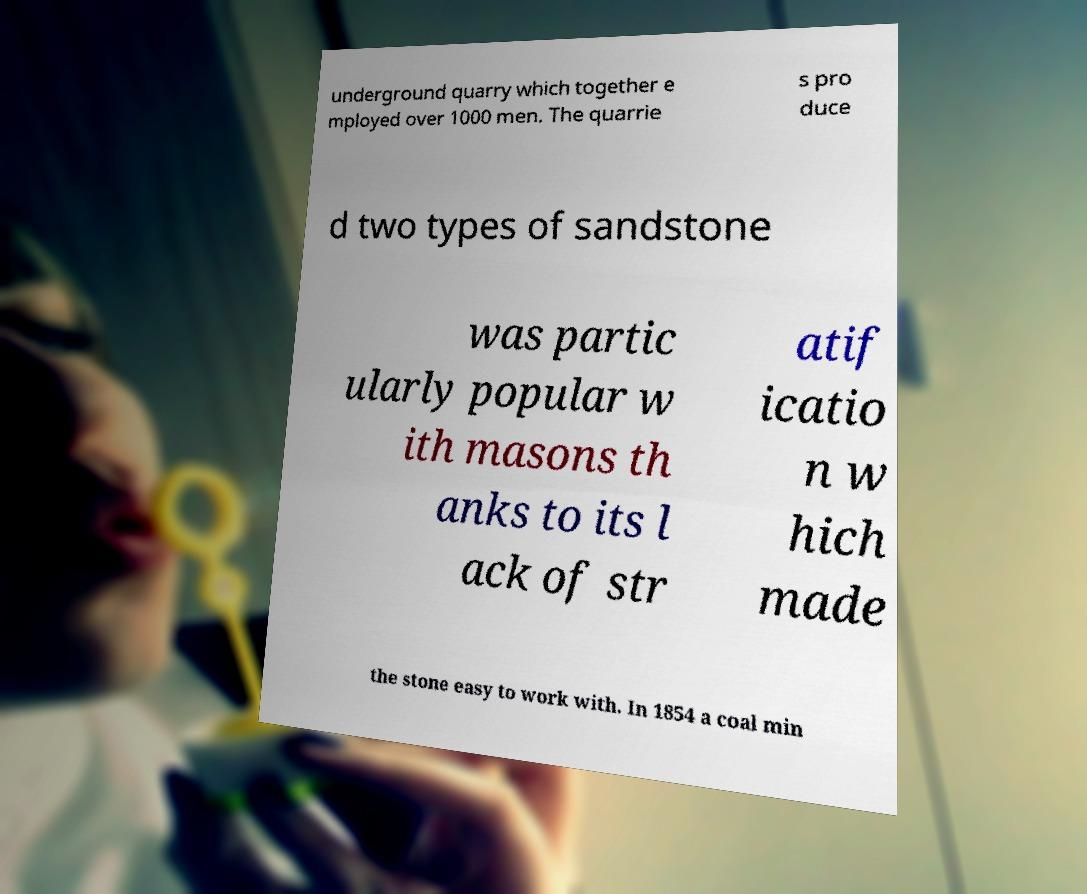I need the written content from this picture converted into text. Can you do that? underground quarry which together e mployed over 1000 men. The quarrie s pro duce d two types of sandstone was partic ularly popular w ith masons th anks to its l ack of str atif icatio n w hich made the stone easy to work with. In 1854 a coal min 